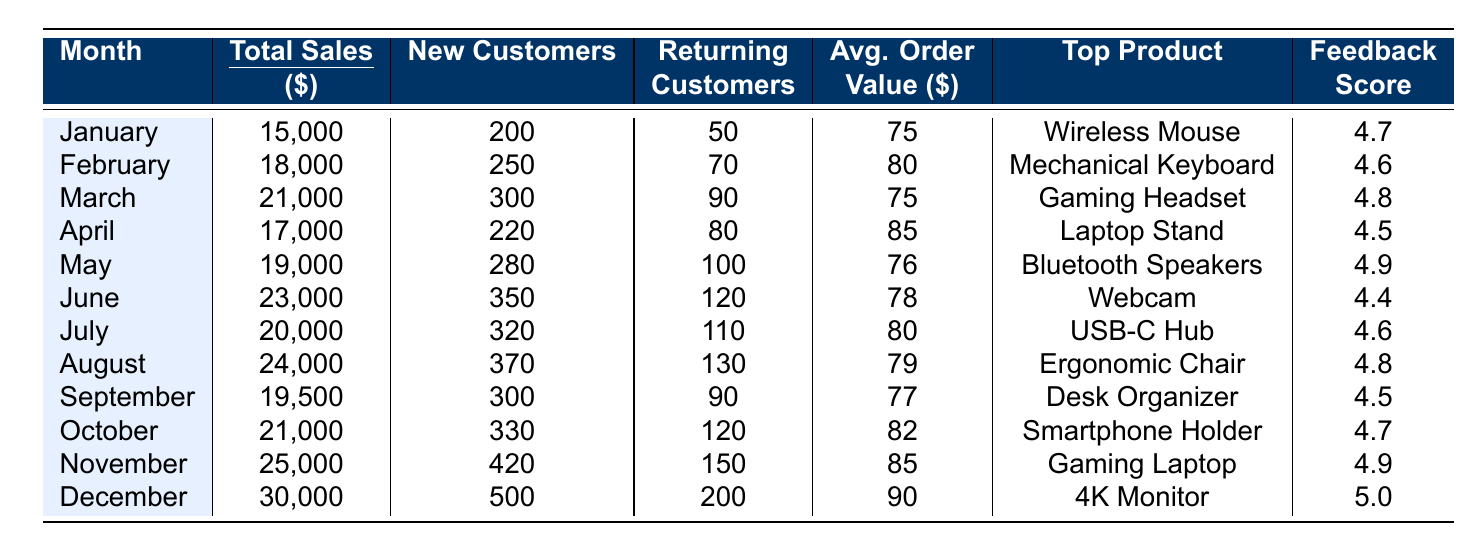What was the total sales in December? Referring to the table, the total sales for December is clearly stated as 30,000.
Answer: 30,000 How many new customers were acquired in July? Looking at the table, new customers for July are shown as 320.
Answer: 320 What is the average order value in November? The average order value for November is displayed in the table as 85.
Answer: 85 Which month had the highest customer feedback score? The feedback scores for each month show December with a score of 5.0, which is the highest among all months.
Answer: December What was the change in total sales from January to March? Total sales for January were 15,000 and for March were 21,000. The change is calculated as 21,000 - 15,000 = 6,000.
Answer: 6,000 How many total customers were new in 2022? Sum the new customers across all months: 200 + 250 + 300 + 220 + 280 + 350 + 320 + 370 + 300 + 330 + 420 + 500 = 3,870.
Answer: 3,870 Was the average order value in August higher or lower than that of April? August has an average order value of 79, while April has an average of 85. Comparing these values, August's value is lower than April's.
Answer: Lower Which month saw a decrease in total sales compared to the previous month? By examining the sales figures: June (23,000) to July (20,000) shows a decrease in sales.
Answer: July What was the total sales for the second half of the year? Adding the total sales from July to December: 20,000 + 24,000 + 19,500 + 21,000 + 25,000 + 30,000 = 139,500.
Answer: 139,500 What percentage of total sales in November was made from new customers? In November, total sales were 25,000 and new customers were 420. Calculate the average order value from new customers: 25,000 / 420 = 59.52. The percentage of sales from new customers is approximately 59.52%.
Answer: 59.52% How did the customer feedback score change from January to December? January's score is 4.7 and December's score is 5.0. The change is 5.0 - 4.7 = 0.3, indicating an improvement.
Answer: Improved by 0.3 What was the total sales for the first quarter (Q1)? Total sales for Q1 are January (15,000) + February (18,000) + March (21,000) = 54,000.
Answer: 54,000 Which product had the highest feedback score and what was it? The product with the highest feedback score was the 4K Monitor in December, scoring 5.0.
Answer: 4K Monitor, 5.0 Did any month have more returning customers than new customers? Yes, in January, there were 50 returning customers compared to 200 new customers, indicating January had higher new customers than returning. However, months like November with 150 returning to 420 new indicates both categories need context for the comparison required.
Answer: Yes for November and January respectively 